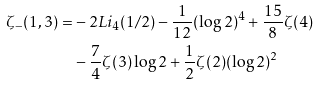<formula> <loc_0><loc_0><loc_500><loc_500>\zeta _ { - } ( 1 , 3 ) = & - 2 L i _ { 4 } ( 1 / 2 ) - \frac { 1 } { 1 2 } ( \log 2 ) ^ { 4 } + \frac { 1 5 } { 8 } \zeta ( 4 ) \\ & - \frac { 7 } { 4 } \zeta ( 3 ) \log 2 + \frac { 1 } { 2 } \zeta ( 2 ) ( \log 2 ) ^ { 2 }</formula> 